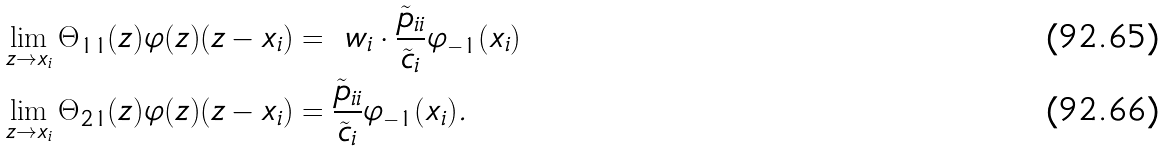<formula> <loc_0><loc_0><loc_500><loc_500>\lim _ { z \to x _ { i } } \Theta _ { 1 1 } ( z ) \varphi ( z ) ( z - x _ { i } ) & = \ w _ { i } \cdot \frac { \tilde { p } _ { i i } } { \tilde { c } _ { i } } \varphi _ { - 1 } ( x _ { i } ) \\ \lim _ { z \to x _ { i } } \Theta _ { 2 1 } ( z ) \varphi ( z ) ( z - x _ { i } ) & = \frac { \tilde { p } _ { i i } } { \tilde { c } _ { i } } \varphi _ { - 1 } ( x _ { i } ) .</formula> 